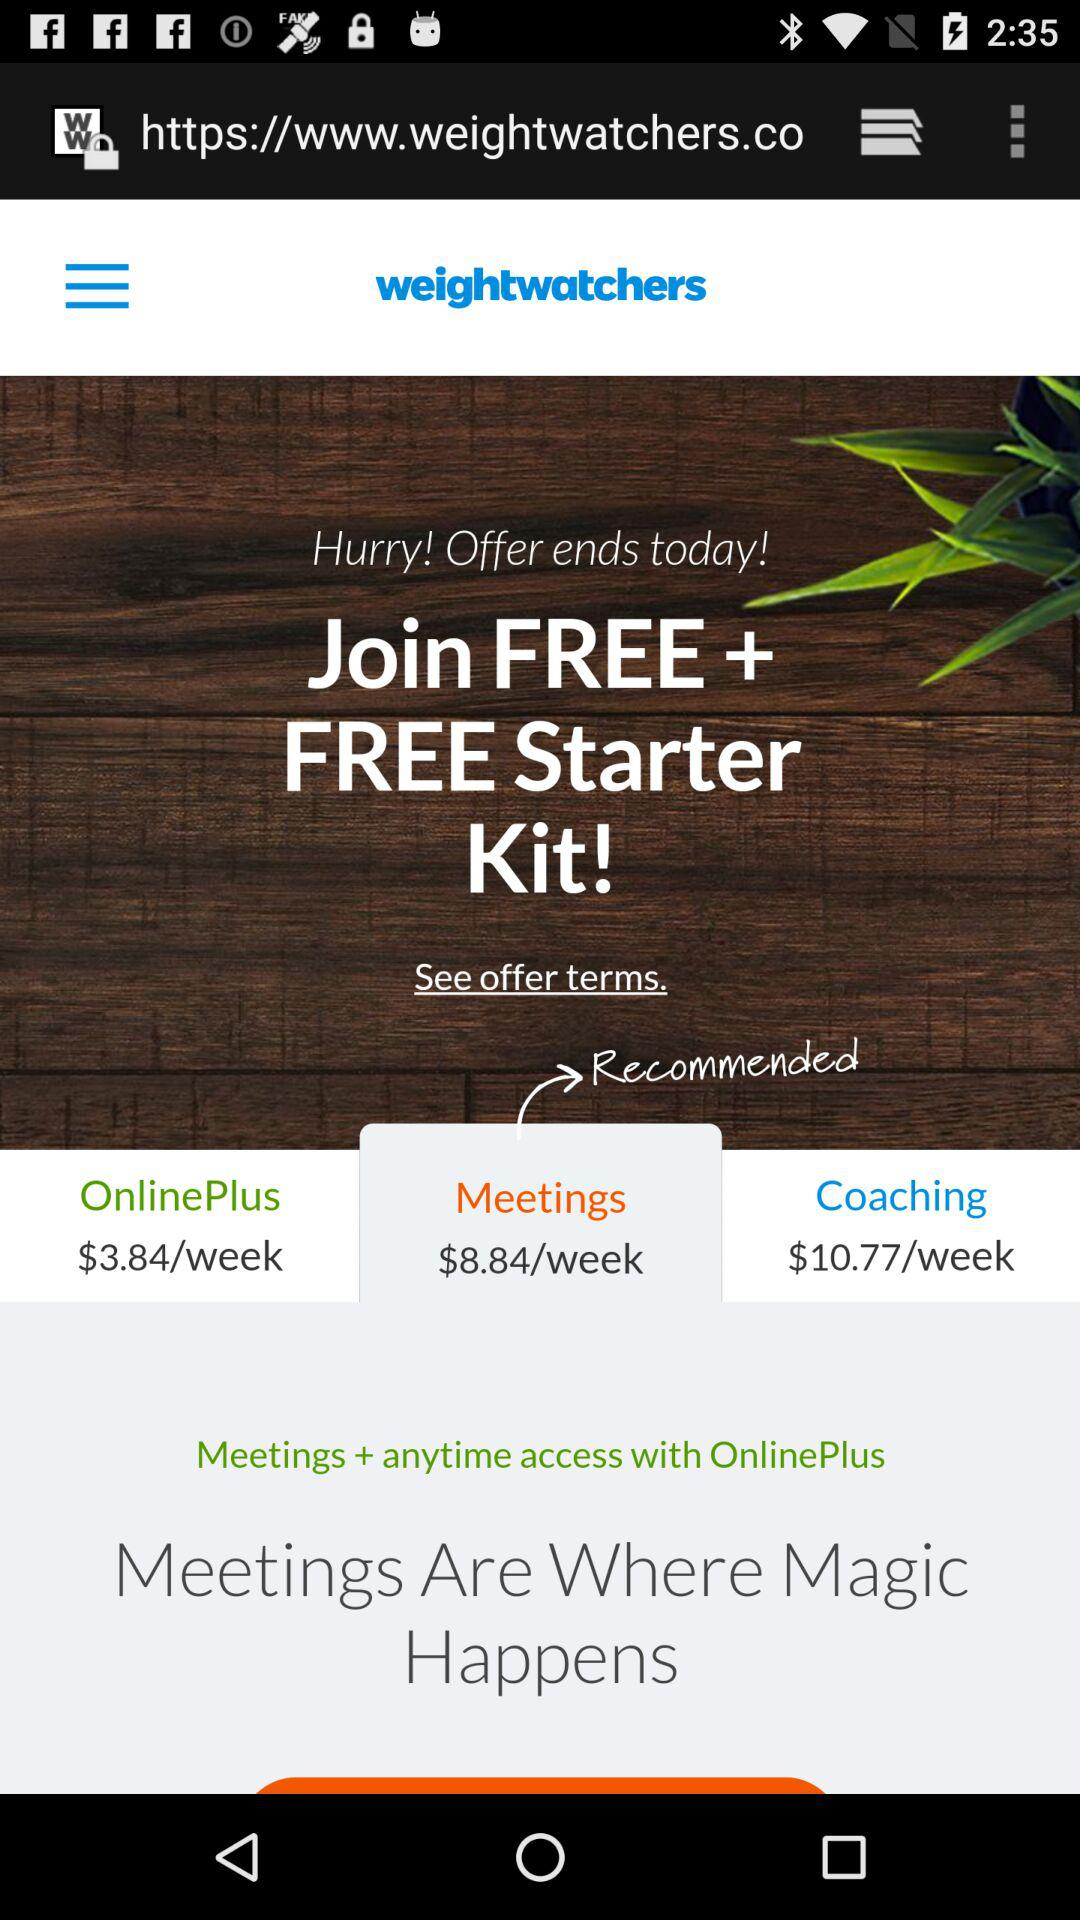What is the price of the "Coaching"? The price of the "Coaching" is $10.77 per week. 